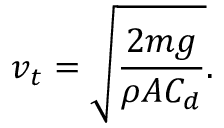<formula> <loc_0><loc_0><loc_500><loc_500>v _ { t } = { \sqrt { \frac { 2 m g } { \rho A C _ { d } } } } .</formula> 